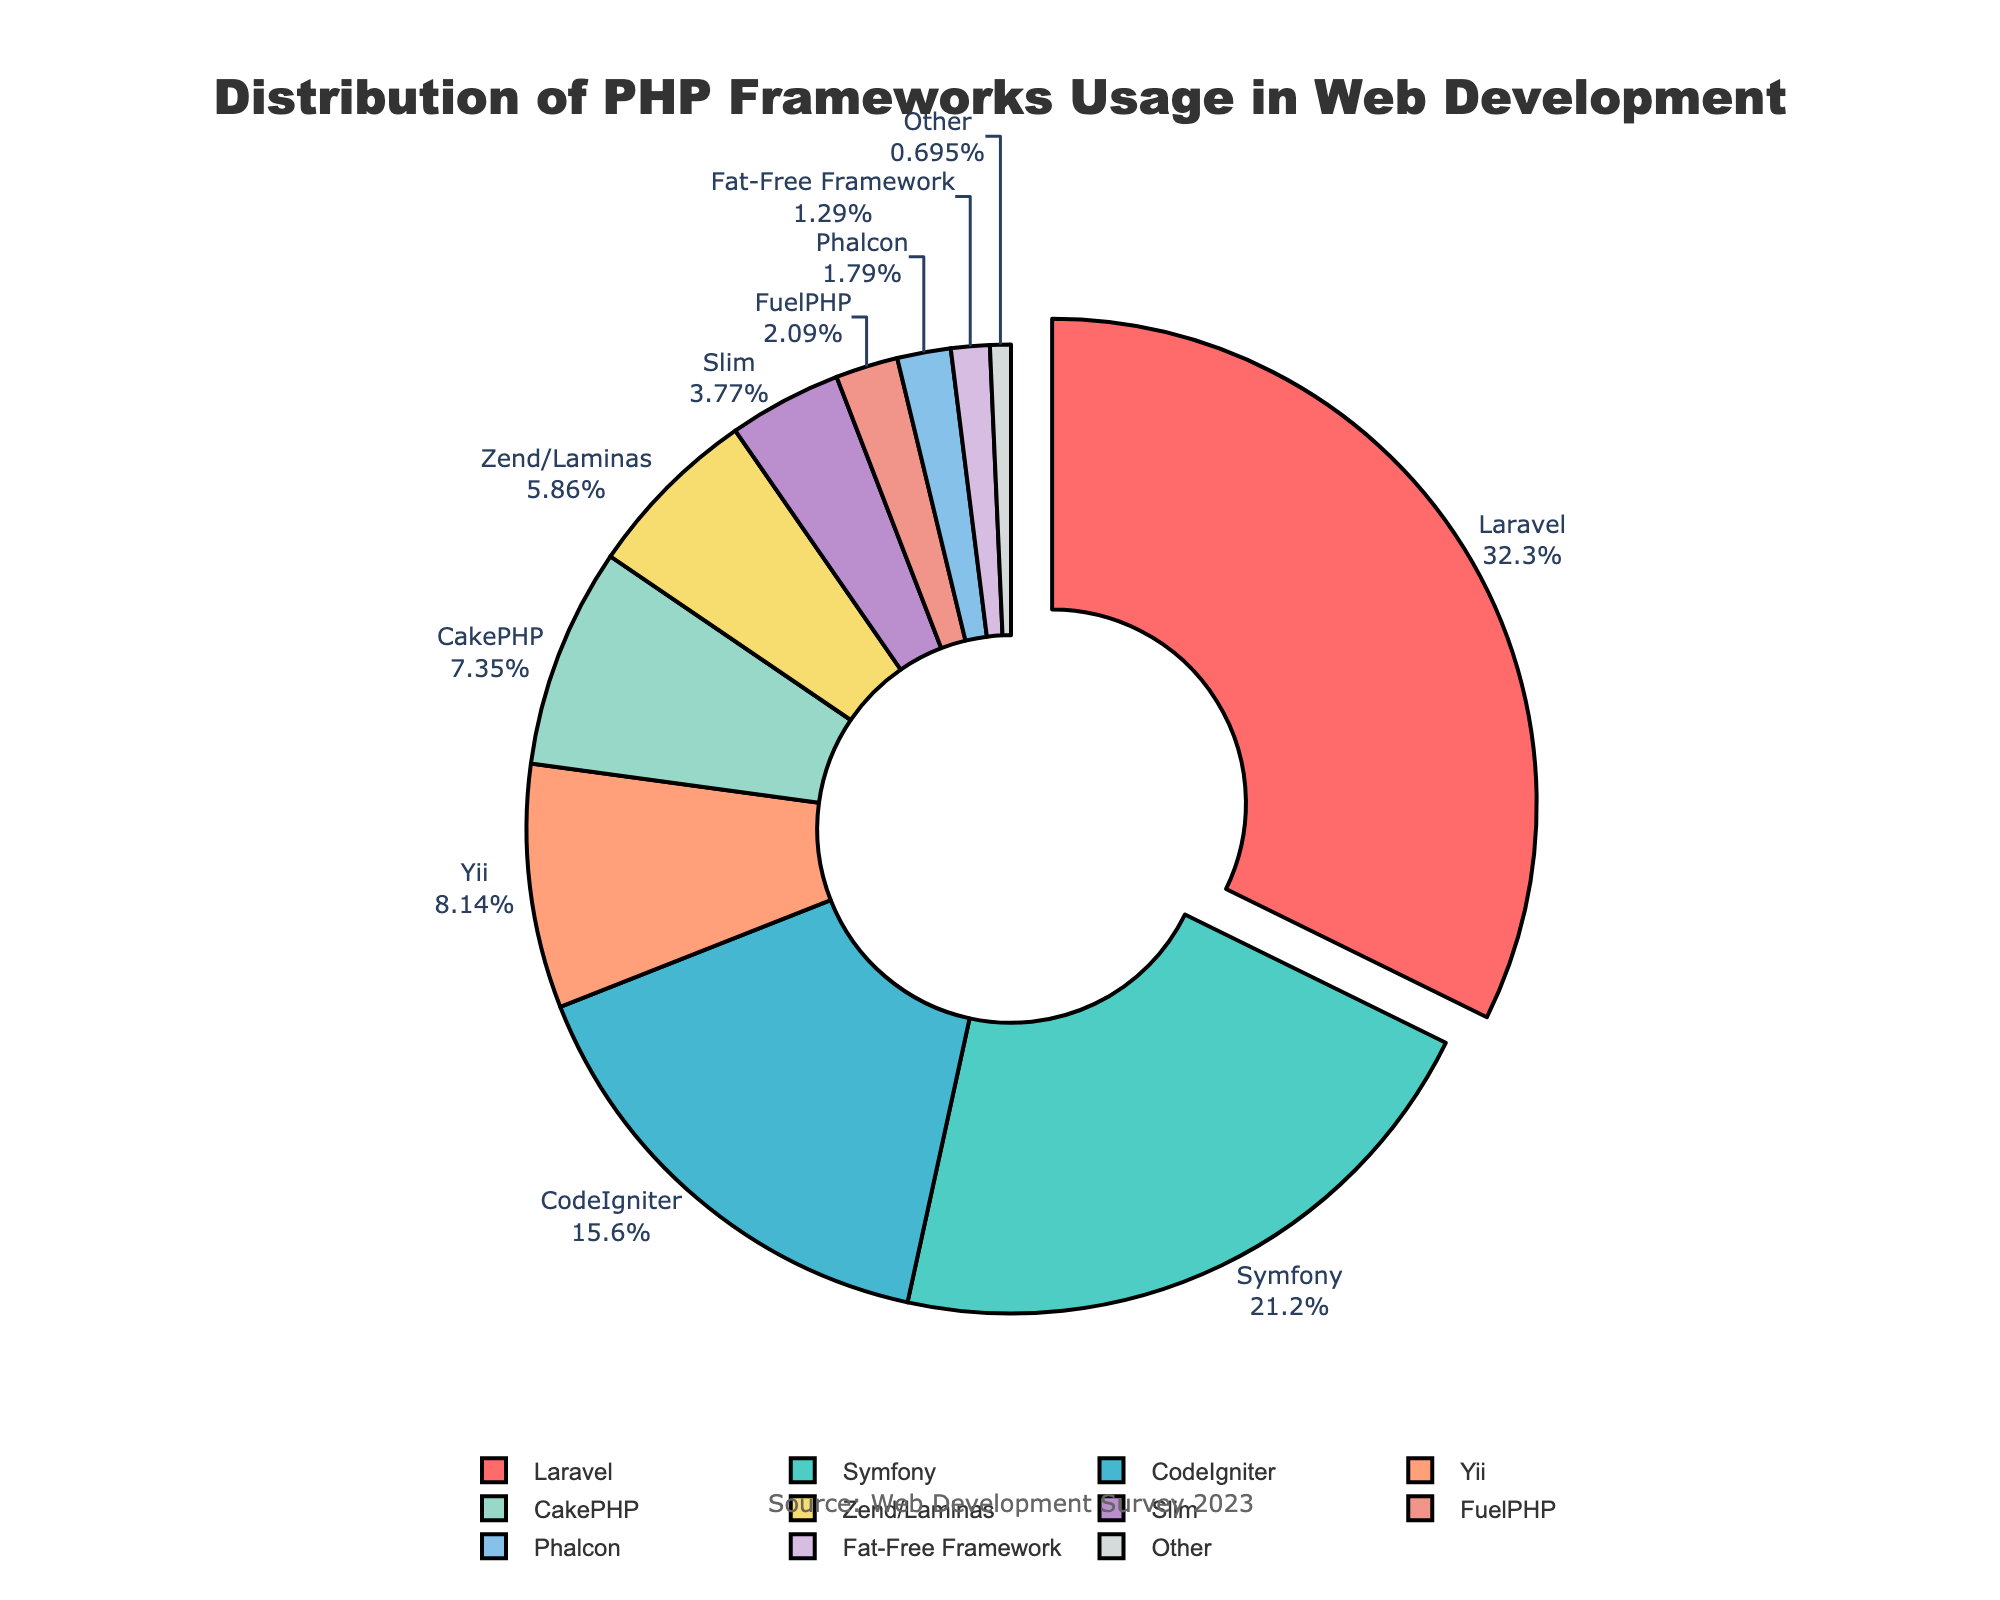What's the most used framework? The pie chart shows the distribution of PHP frameworks usage in percentages. The largest segment, denoted as 32.5%, corresponds to Laravel, indicating it's the most used framework.
Answer: Laravel Which framework has the second-highest usage after Laravel? The pie chart shows the distribution of PHP frameworks usage. After Laravel, which has the highest percentage (32.5%), the next largest segment is 21.3%, representing Symfony.
Answer: Symfony What's the total percentage of usage for Laravel, Symfony, and CodeIgniter combined? To find the total percentage for these three frameworks, add their individual percentages: Laravel (32.5%) + Symfony (21.3%) + CodeIgniter (15.7%) = 69.5%.
Answer: 69.5% How does the usage of Yii compare to CakePHP? The pie chart shows that Yii has 8.2% while CakePHP has 7.4%. Comparing these values, Yii's usage is higher than CakePHP's usage.
Answer: Yii's usage is higher Which framework usage is represented by the smallest segment? The smallest segment in the pie chart corresponds to a usage percentage of 0.7%, which is labeled as "Other."
Answer: Other What is the percentage difference between Zend/Laminas and Slim? The pie chart shows Zend/Laminas with 5.9% and Slim with 3.8%. The difference between these percentages is calculated as 5.9% - 3.8% = 2.1%.
Answer: 2.1% Which frameworks have usages less than 5%? Examining the pie chart, frameworks with usage percentages less than 5% are Slim (3.8%), FuelPHP (2.1%), Phalcon (1.8%), Fat-Free Framework (1.3%), and Other (0.7%).
Answer: Slim, FuelPHP, Phalcon, Fat-Free Framework, Other What is the combined percentage of frameworks with usage greater than 10%? Frameworks with usage percentages greater than 10% are Laravel (32.5%), Symfony (21.3%), and CodeIgniter (15.7%). Their combined percentage is 32.5% + 21.3% + 15.7% = 69.5%.
Answer: 69.5% How much more popular is Laravel compared to the sum of the least used frameworks (FuelPHP, Phalcon, Fat-Free Framework, Other)? Laravel's usage is 32.5%. The sum of FuelPHP (2.1%), Phalcon (1.8%), Fat-Free Framework (1.3%), and Other (0.7%) is 5.9%. The difference is 32.5% - 5.9% = 26.6%.
Answer: 26.6% 